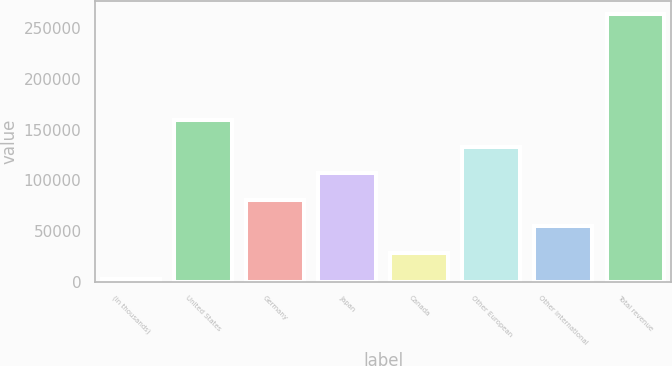Convert chart. <chart><loc_0><loc_0><loc_500><loc_500><bar_chart><fcel>(in thousands)<fcel>United States<fcel>Germany<fcel>Japan<fcel>Canada<fcel>Other European<fcel>Other international<fcel>Total revenue<nl><fcel>2006<fcel>158986<fcel>80496.2<fcel>106660<fcel>28169.4<fcel>132823<fcel>54332.8<fcel>263640<nl></chart> 